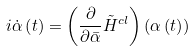Convert formula to latex. <formula><loc_0><loc_0><loc_500><loc_500>i \dot { \alpha } \left ( t \right ) = \left ( \frac { \partial } { \partial \bar { \alpha } } \tilde { H } ^ { c l } \right ) \left ( \alpha \left ( t \right ) \right )</formula> 